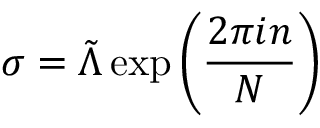<formula> <loc_0><loc_0><loc_500><loc_500>\sigma = \tilde { \Lambda } \exp \left ( \frac { 2 \pi i n } { N } \right )</formula> 